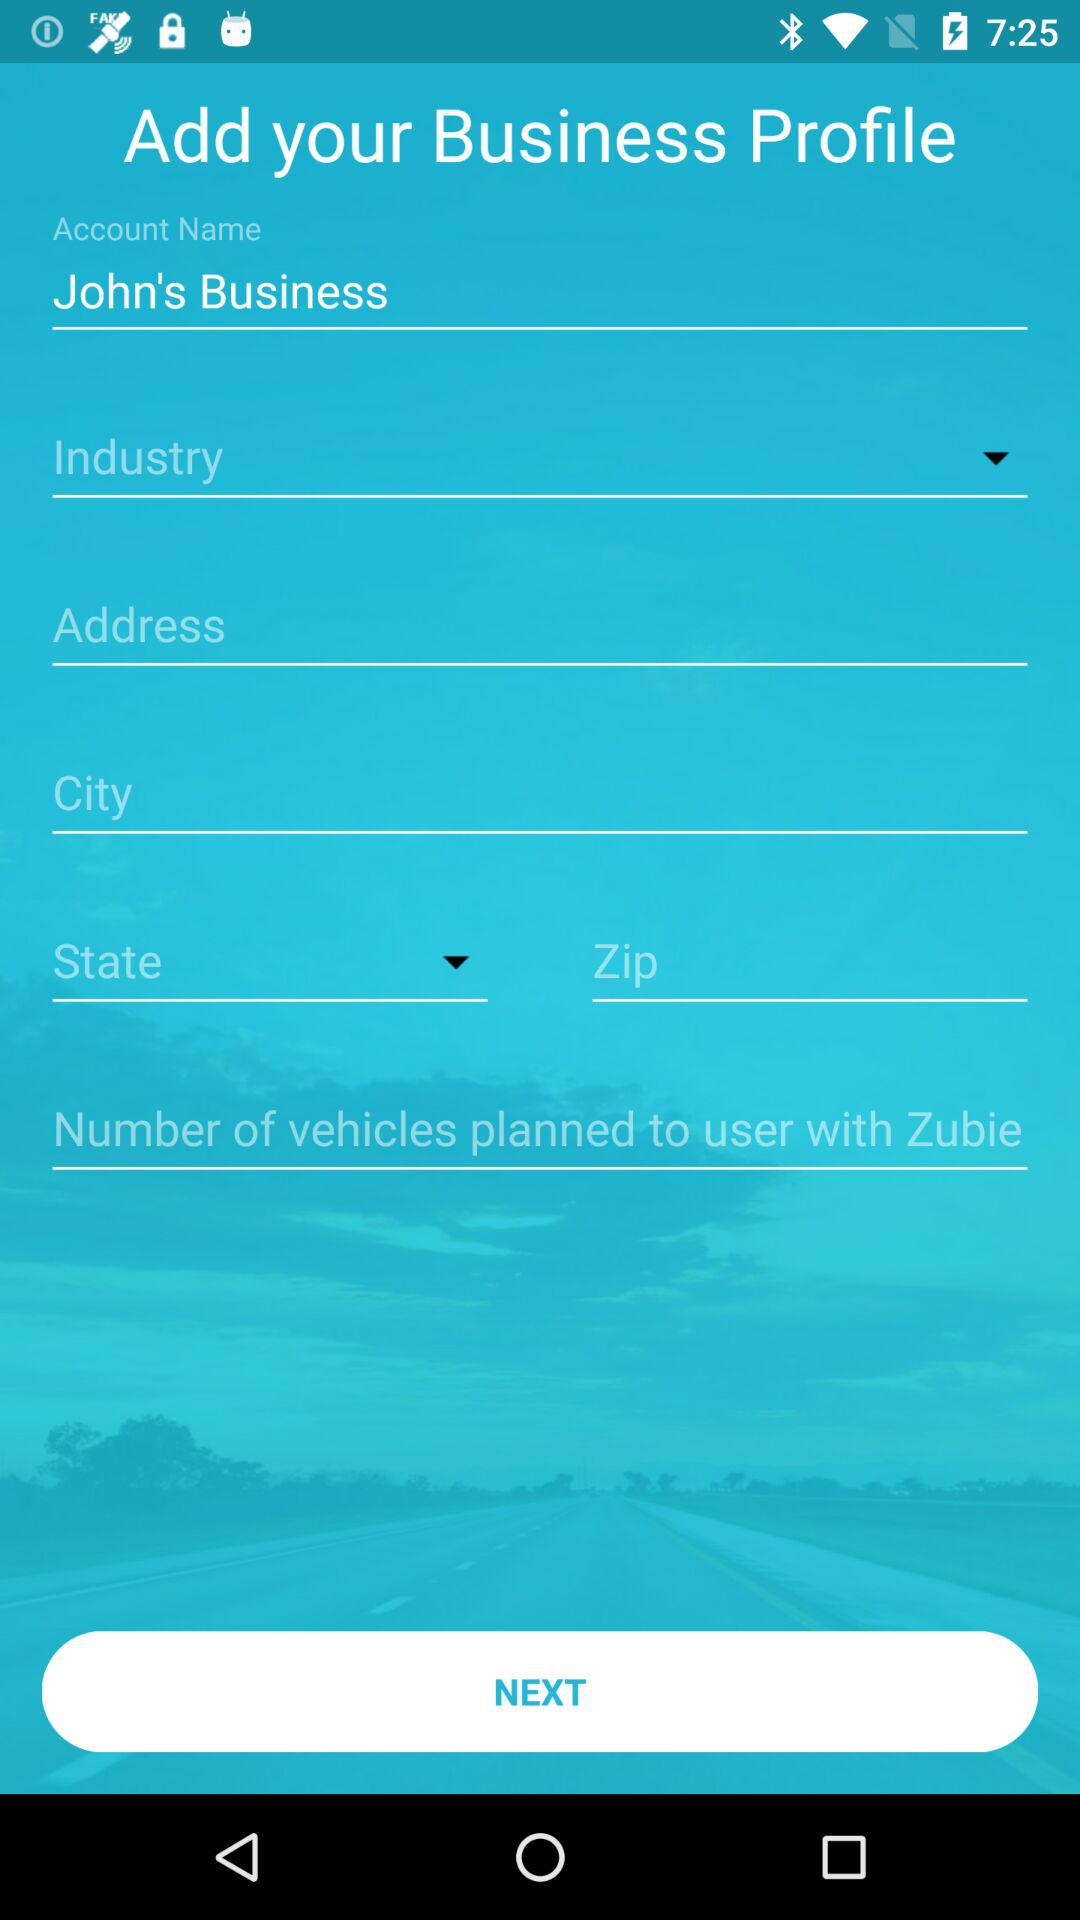What is the account name? The account name is "John's Business". 